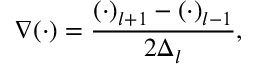Convert formula to latex. <formula><loc_0><loc_0><loc_500><loc_500>\nabla ( \cdot ) = \frac { ( \cdot ) _ { l + 1 } - ( \cdot ) _ { l - 1 } } { 2 \Delta _ { l } } ,</formula> 